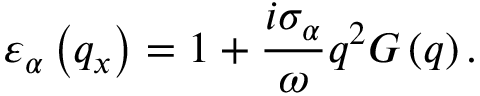<formula> <loc_0><loc_0><loc_500><loc_500>{ { \varepsilon } _ { \alpha } } \left ( { { q } _ { x } } \right ) = 1 + \frac { i { { \sigma } _ { \alpha } } } { \omega } { { q } ^ { 2 } } G \left ( q \right ) .</formula> 